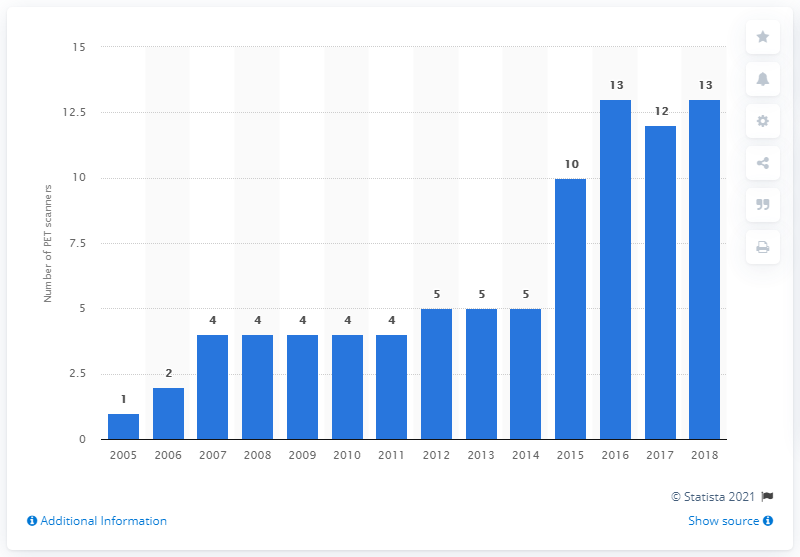Draw attention to some important aspects in this diagram. There were 13 PET scanners in Greece in 2018. 